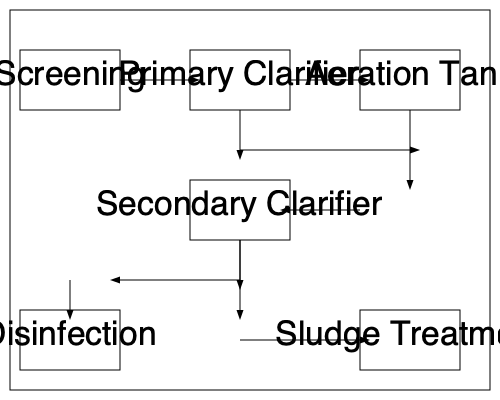In the wastewater treatment process flow diagram, which stage directly follows the Aeration Tank and what is its primary function? To answer this question, let's analyze the flow diagram step-by-step:

1. The wastewater treatment process starts with Screening.
2. It then flows to the Primary Clarifier.
3. From the Primary Clarifier, the water moves to the Aeration Tank.
4. After the Aeration Tank, we can see that the flow leads directly to the Secondary Clarifier.

The Secondary Clarifier's primary function in a wastewater treatment process is to separate the biological solids (activated sludge) from the treated water. This stage is crucial because:

1. It allows the settling of microorganisms and other particulates that were mixed with the wastewater in the Aeration Tank.
2. It produces a clearer effluent that can move on to further treatment or discharge.
3. It enables the collection of settled sludge, some of which is typically recycled back to the Aeration Tank to maintain the biological process, while excess sludge is removed for further treatment.

The Secondary Clarifier is an essential step in ensuring the quality of the treated water before it moves on to the final stages of treatment (Disinfection in this case) and eventual discharge.
Answer: Secondary Clarifier; separation of biological solids from treated water 